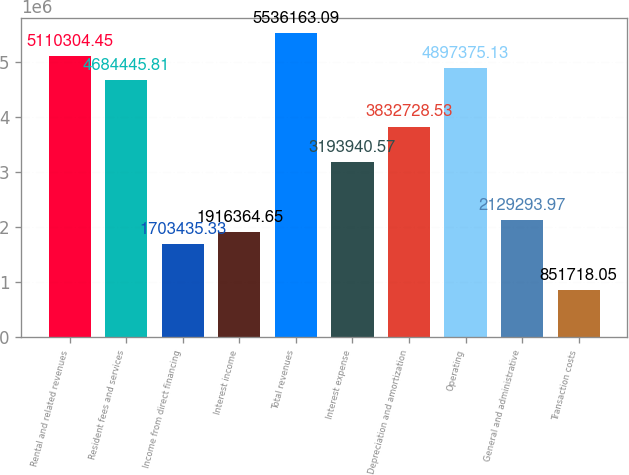Convert chart to OTSL. <chart><loc_0><loc_0><loc_500><loc_500><bar_chart><fcel>Rental and related revenues<fcel>Resident fees and services<fcel>Income from direct financing<fcel>Interest income<fcel>Total revenues<fcel>Interest expense<fcel>Depreciation and amortization<fcel>Operating<fcel>General and administrative<fcel>Transaction costs<nl><fcel>5.1103e+06<fcel>4.68445e+06<fcel>1.70344e+06<fcel>1.91636e+06<fcel>5.53616e+06<fcel>3.19394e+06<fcel>3.83273e+06<fcel>4.89738e+06<fcel>2.12929e+06<fcel>851718<nl></chart> 